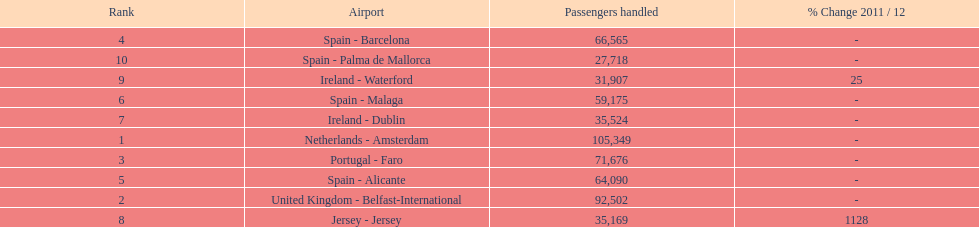How many airports in spain are among the 10 busiest routes to and from london southend airport in 2012? 4. 